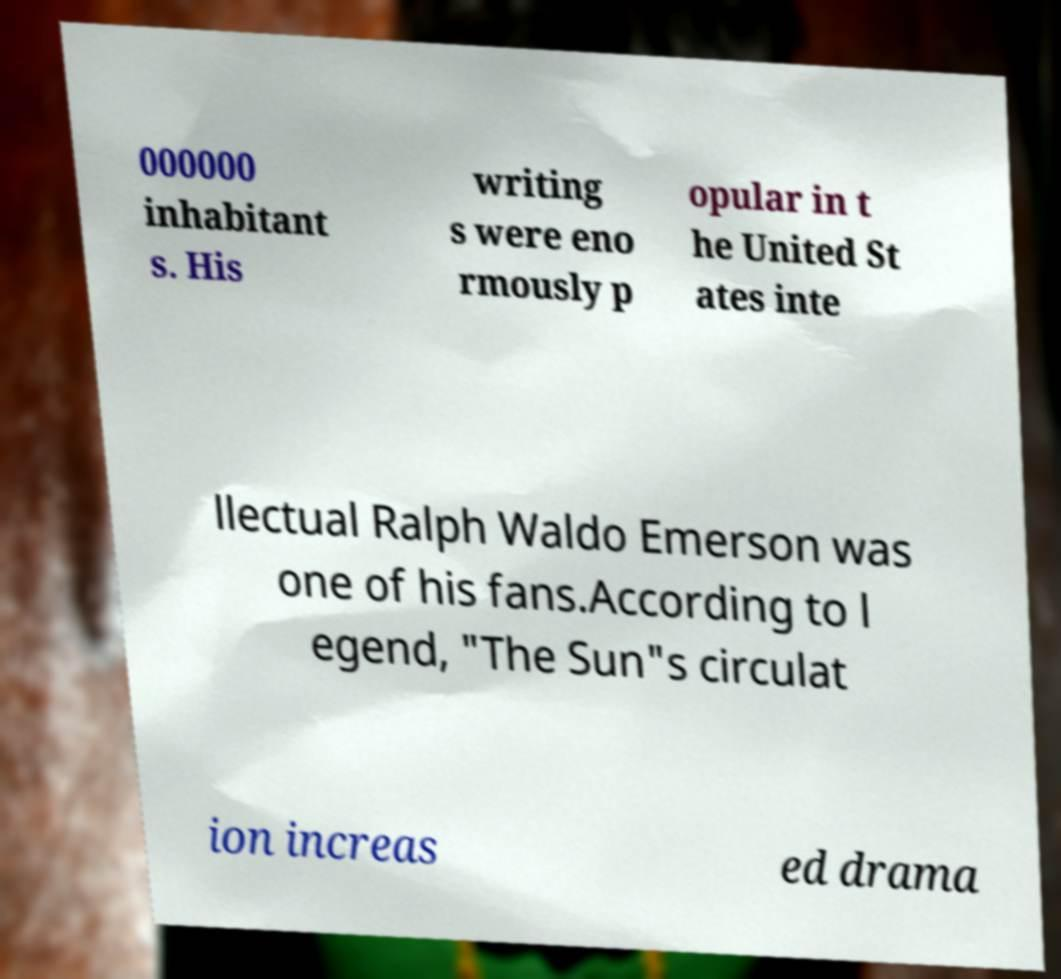Please identify and transcribe the text found in this image. 000000 inhabitant s. His writing s were eno rmously p opular in t he United St ates inte llectual Ralph Waldo Emerson was one of his fans.According to l egend, "The Sun"s circulat ion increas ed drama 